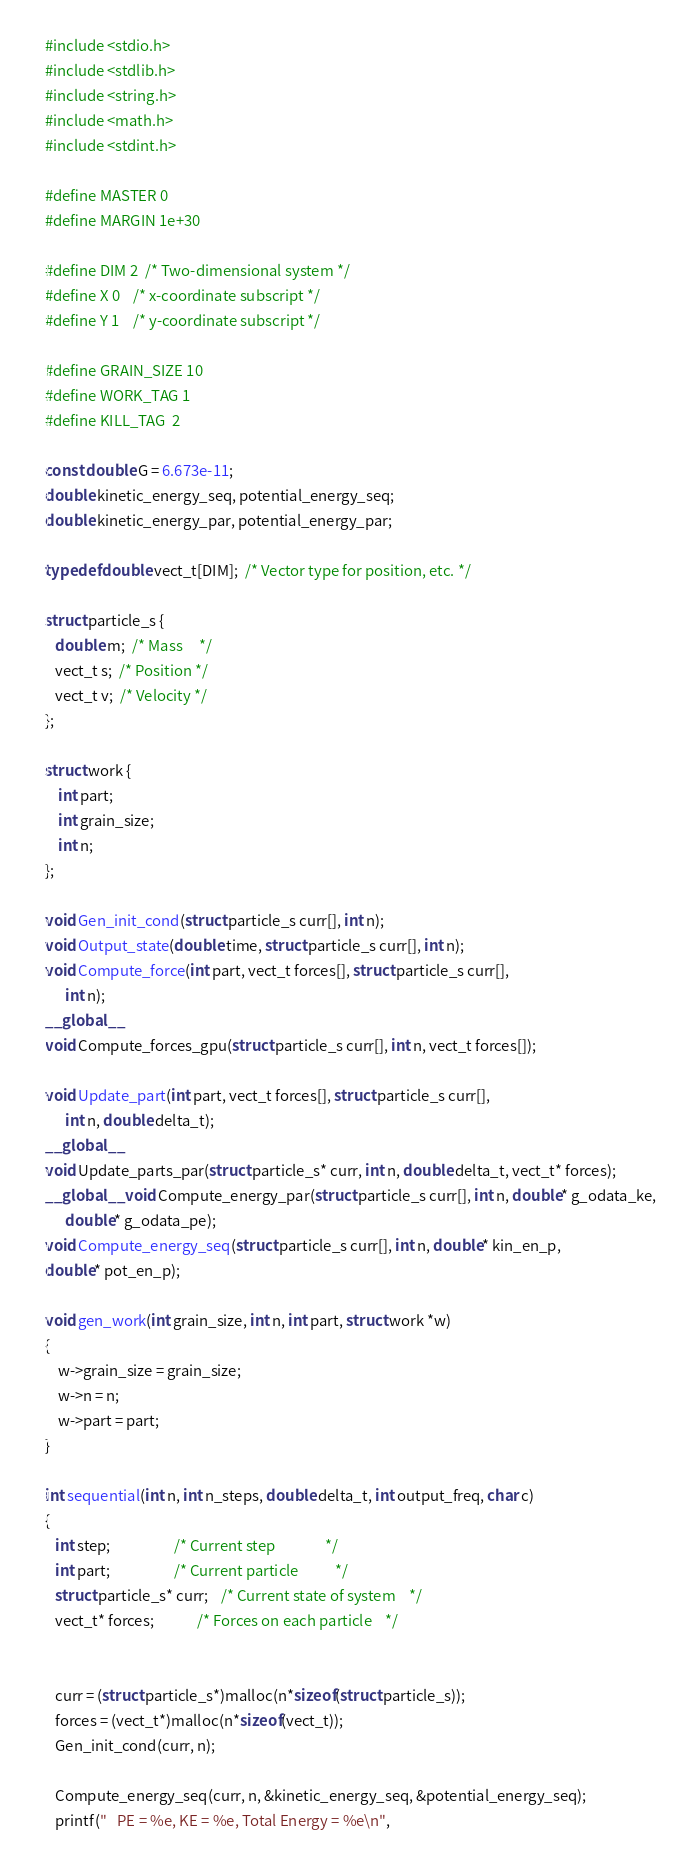Convert code to text. <code><loc_0><loc_0><loc_500><loc_500><_Cuda_>#include <stdio.h>
#include <stdlib.h>
#include <string.h>
#include <math.h>
#include <stdint.h>

#define MASTER 0
#define MARGIN 1e+30

#define DIM 2  /* Two-dimensional system */
#define X 0    /* x-coordinate subscript */
#define Y 1    /* y-coordinate subscript */

#define GRAIN_SIZE 10
#define WORK_TAG 1
#define KILL_TAG  2

const double G = 6.673e-11;  
double kinetic_energy_seq, potential_energy_seq;
double kinetic_energy_par, potential_energy_par;

typedef double vect_t[DIM];  /* Vector type for position, etc. */

struct particle_s {
   double m;  /* Mass     */
   vect_t s;  /* Position */
   vect_t v;  /* Velocity */
};

struct work {
    int part;
    int grain_size;
    int n;
};

void Gen_init_cond(struct particle_s curr[], int n);
void Output_state(double time, struct particle_s curr[], int n);
void Compute_force(int part, vect_t forces[], struct particle_s curr[], 
      int n);
__global__
void Compute_forces_gpu(struct particle_s curr[], int n, vect_t forces[]);

void Update_part(int part, vect_t forces[], struct particle_s curr[], 
      int n, double delta_t);
__global__
void Update_parts_par(struct particle_s* curr, int n, double delta_t, vect_t* forces);
__global__ void Compute_energy_par(struct particle_s curr[], int n, double* g_odata_ke,
      double* g_odata_pe);
void Compute_energy_seq(struct particle_s curr[], int n, double* kin_en_p,
double* pot_en_p);

void gen_work(int grain_size, int n, int part, struct work *w)
{
    w->grain_size = grain_size;
    w->n = n;
    w->part = part;
}

int sequential(int n, int n_steps, double delta_t, int output_freq, char c)
{
   int step;                   /* Current step               */
   int part;                   /* Current particle           */
   struct particle_s* curr;    /* Current state of system    */
   vect_t* forces;             /* Forces on each particle    */

   
   curr = (struct particle_s*)malloc(n*sizeof(struct particle_s));
   forces = (vect_t*)malloc(n*sizeof(vect_t));
   Gen_init_cond(curr, n);

   Compute_energy_seq(curr, n, &kinetic_energy_seq, &potential_energy_seq);
   printf("   PE = %e, KE = %e, Total Energy = %e\n",</code> 